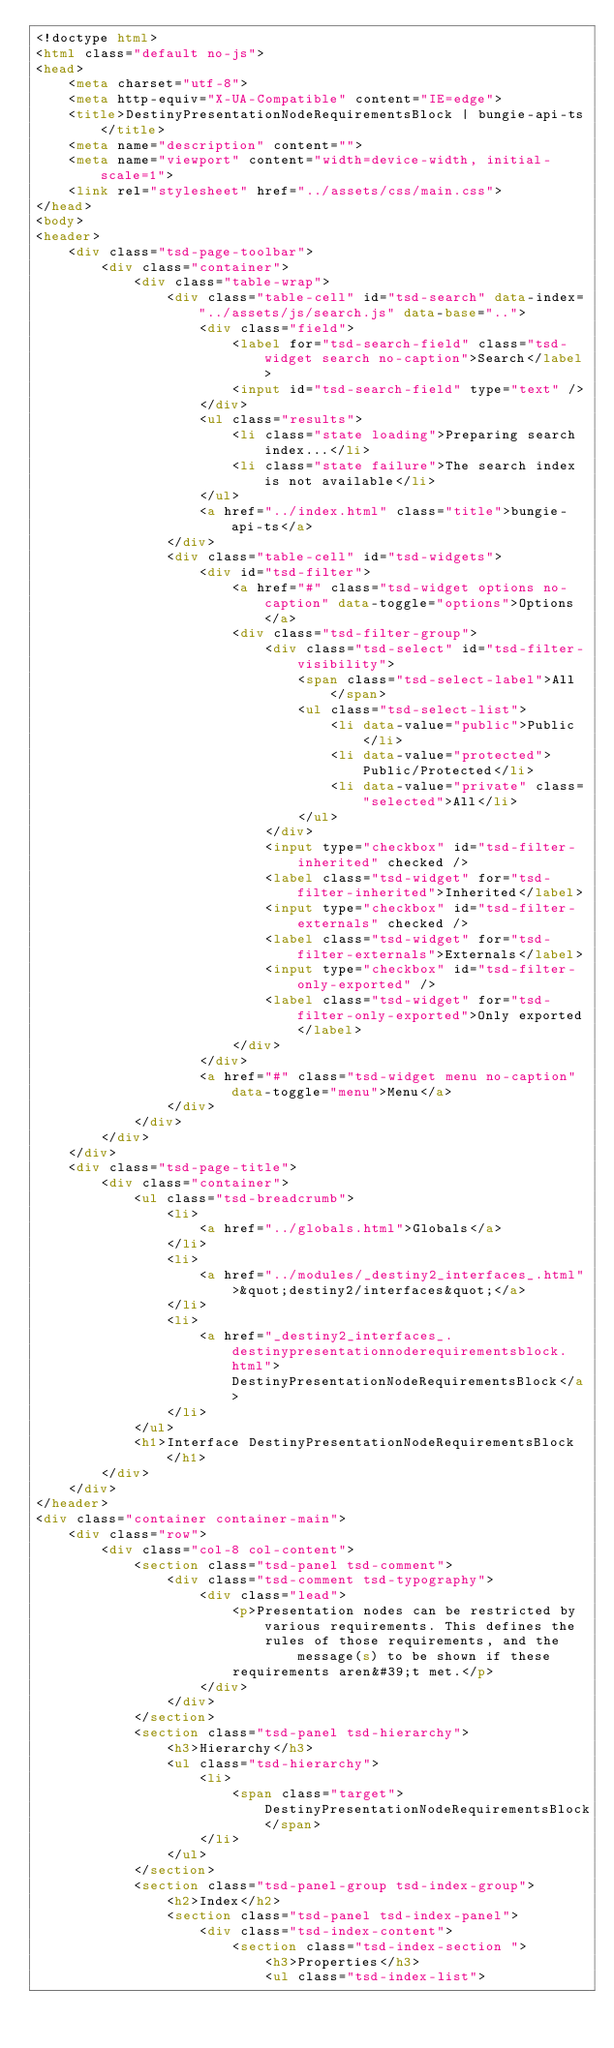Convert code to text. <code><loc_0><loc_0><loc_500><loc_500><_HTML_><!doctype html>
<html class="default no-js">
<head>
	<meta charset="utf-8">
	<meta http-equiv="X-UA-Compatible" content="IE=edge">
	<title>DestinyPresentationNodeRequirementsBlock | bungie-api-ts</title>
	<meta name="description" content="">
	<meta name="viewport" content="width=device-width, initial-scale=1">
	<link rel="stylesheet" href="../assets/css/main.css">
</head>
<body>
<header>
	<div class="tsd-page-toolbar">
		<div class="container">
			<div class="table-wrap">
				<div class="table-cell" id="tsd-search" data-index="../assets/js/search.js" data-base="..">
					<div class="field">
						<label for="tsd-search-field" class="tsd-widget search no-caption">Search</label>
						<input id="tsd-search-field" type="text" />
					</div>
					<ul class="results">
						<li class="state loading">Preparing search index...</li>
						<li class="state failure">The search index is not available</li>
					</ul>
					<a href="../index.html" class="title">bungie-api-ts</a>
				</div>
				<div class="table-cell" id="tsd-widgets">
					<div id="tsd-filter">
						<a href="#" class="tsd-widget options no-caption" data-toggle="options">Options</a>
						<div class="tsd-filter-group">
							<div class="tsd-select" id="tsd-filter-visibility">
								<span class="tsd-select-label">All</span>
								<ul class="tsd-select-list">
									<li data-value="public">Public</li>
									<li data-value="protected">Public/Protected</li>
									<li data-value="private" class="selected">All</li>
								</ul>
							</div>
							<input type="checkbox" id="tsd-filter-inherited" checked />
							<label class="tsd-widget" for="tsd-filter-inherited">Inherited</label>
							<input type="checkbox" id="tsd-filter-externals" checked />
							<label class="tsd-widget" for="tsd-filter-externals">Externals</label>
							<input type="checkbox" id="tsd-filter-only-exported" />
							<label class="tsd-widget" for="tsd-filter-only-exported">Only exported</label>
						</div>
					</div>
					<a href="#" class="tsd-widget menu no-caption" data-toggle="menu">Menu</a>
				</div>
			</div>
		</div>
	</div>
	<div class="tsd-page-title">
		<div class="container">
			<ul class="tsd-breadcrumb">
				<li>
					<a href="../globals.html">Globals</a>
				</li>
				<li>
					<a href="../modules/_destiny2_interfaces_.html">&quot;destiny2/interfaces&quot;</a>
				</li>
				<li>
					<a href="_destiny2_interfaces_.destinypresentationnoderequirementsblock.html">DestinyPresentationNodeRequirementsBlock</a>
				</li>
			</ul>
			<h1>Interface DestinyPresentationNodeRequirementsBlock</h1>
		</div>
	</div>
</header>
<div class="container container-main">
	<div class="row">
		<div class="col-8 col-content">
			<section class="tsd-panel tsd-comment">
				<div class="tsd-comment tsd-typography">
					<div class="lead">
						<p>Presentation nodes can be restricted by various requirements. This defines the
							rules of those requirements, and the message(s) to be shown if these
						requirements aren&#39;t met.</p>
					</div>
				</div>
			</section>
			<section class="tsd-panel tsd-hierarchy">
				<h3>Hierarchy</h3>
				<ul class="tsd-hierarchy">
					<li>
						<span class="target">DestinyPresentationNodeRequirementsBlock</span>
					</li>
				</ul>
			</section>
			<section class="tsd-panel-group tsd-index-group">
				<h2>Index</h2>
				<section class="tsd-panel tsd-index-panel">
					<div class="tsd-index-content">
						<section class="tsd-index-section ">
							<h3>Properties</h3>
							<ul class="tsd-index-list"></code> 